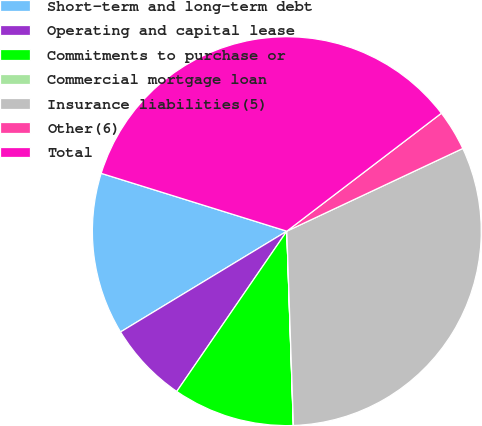Convert chart to OTSL. <chart><loc_0><loc_0><loc_500><loc_500><pie_chart><fcel>Short-term and long-term debt<fcel>Operating and capital lease<fcel>Commitments to purchase or<fcel>Commercial mortgage loan<fcel>Insurance liabilities(5)<fcel>Other(6)<fcel>Total<nl><fcel>13.48%<fcel>6.75%<fcel>10.11%<fcel>0.01%<fcel>31.45%<fcel>3.38%<fcel>34.82%<nl></chart> 